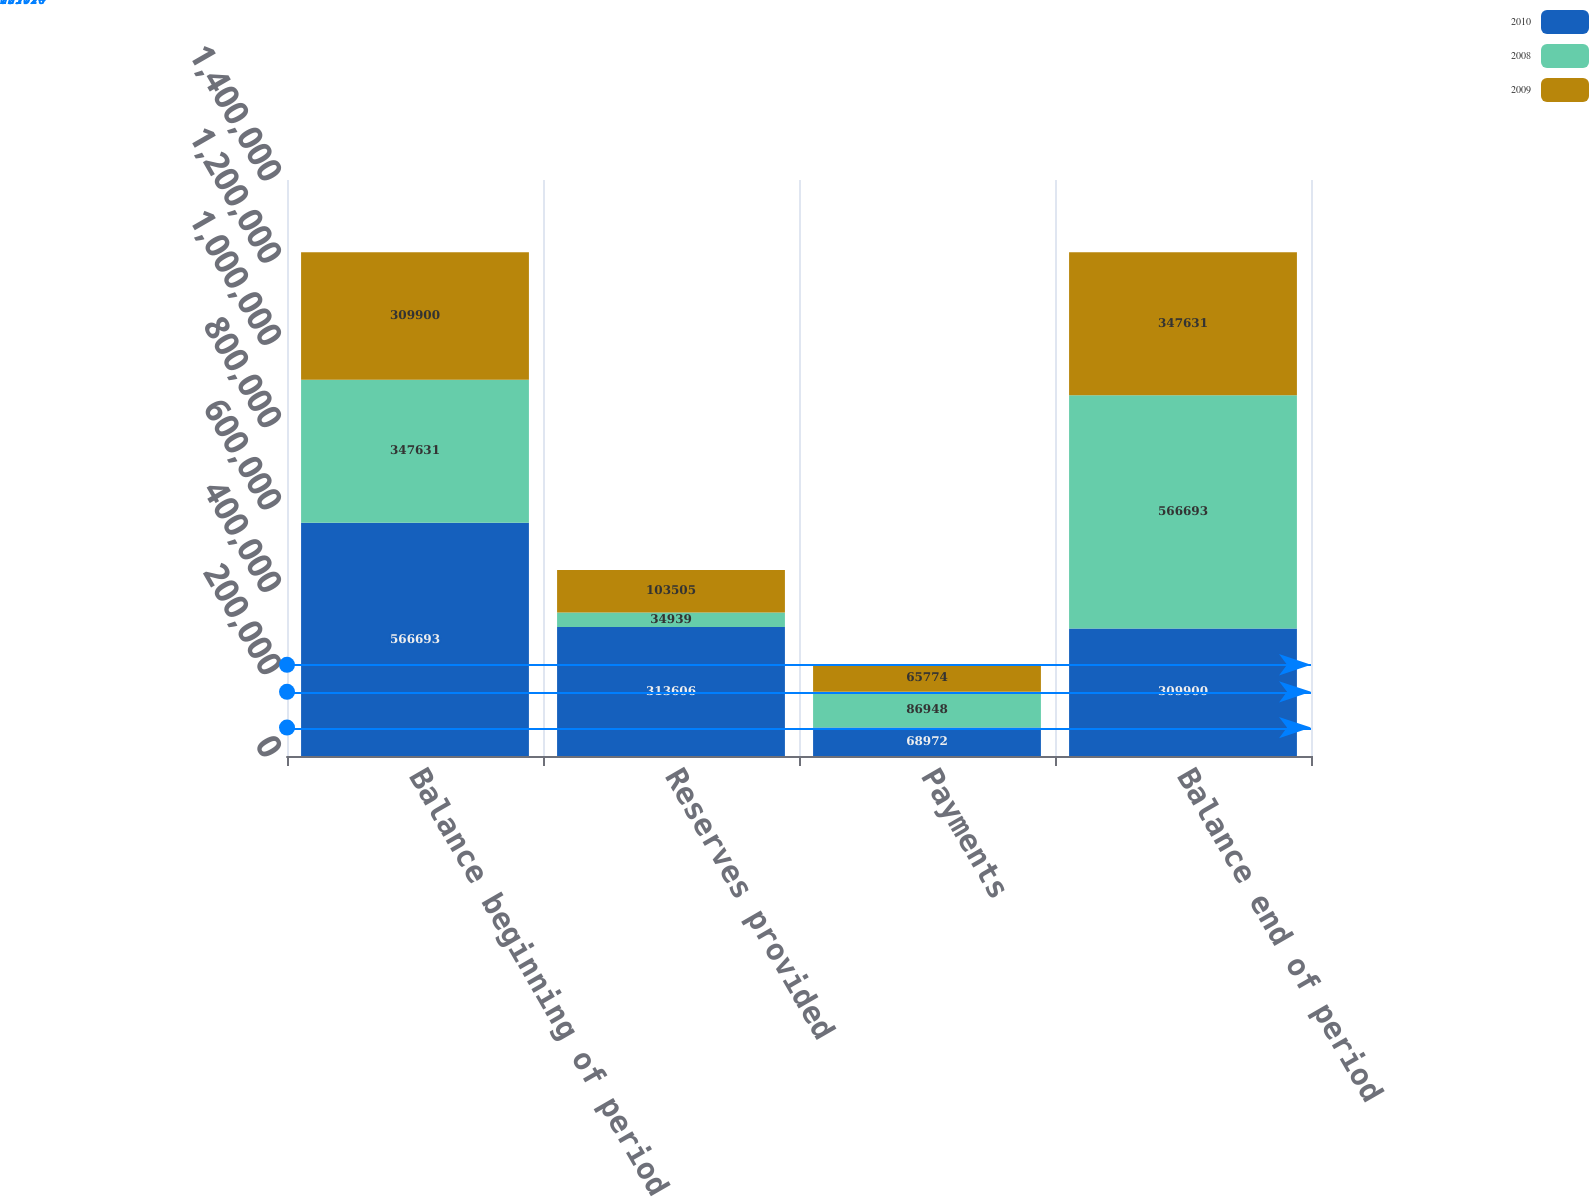Convert chart to OTSL. <chart><loc_0><loc_0><loc_500><loc_500><stacked_bar_chart><ecel><fcel>Balance beginning of period<fcel>Reserves provided<fcel>Payments<fcel>Balance end of period<nl><fcel>2010<fcel>566693<fcel>313606<fcel>68972<fcel>309900<nl><fcel>2008<fcel>347631<fcel>34939<fcel>86948<fcel>566693<nl><fcel>2009<fcel>309900<fcel>103505<fcel>65774<fcel>347631<nl></chart> 